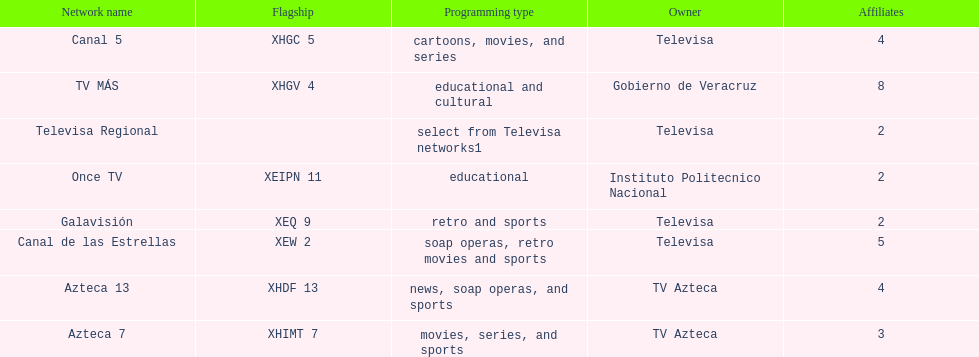Which is the only station with 8 affiliates? TV MÁS. Would you mind parsing the complete table? {'header': ['Network name', 'Flagship', 'Programming type', 'Owner', 'Affiliates'], 'rows': [['Canal 5', 'XHGC 5', 'cartoons, movies, and series', 'Televisa', '4'], ['TV MÁS', 'XHGV 4', 'educational and cultural', 'Gobierno de Veracruz', '8'], ['Televisa Regional', '', 'select from Televisa networks1', 'Televisa', '2'], ['Once TV', 'XEIPN 11', 'educational', 'Instituto Politecnico Nacional', '2'], ['Galavisión', 'XEQ 9', 'retro and sports', 'Televisa', '2'], ['Canal de las Estrellas', 'XEW 2', 'soap operas, retro movies and sports', 'Televisa', '5'], ['Azteca 13', 'XHDF 13', 'news, soap operas, and sports', 'TV Azteca', '4'], ['Azteca 7', 'XHIMT 7', 'movies, series, and sports', 'TV Azteca', '3']]} 